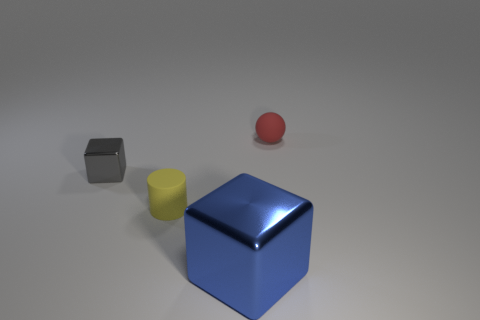Add 2 red rubber cylinders. How many objects exist? 6 Subtract all cylinders. How many objects are left? 3 Add 3 big metal cubes. How many big metal cubes are left? 4 Add 4 large spheres. How many large spheres exist? 4 Subtract 1 yellow cylinders. How many objects are left? 3 Subtract all big blue cubes. Subtract all red balls. How many objects are left? 2 